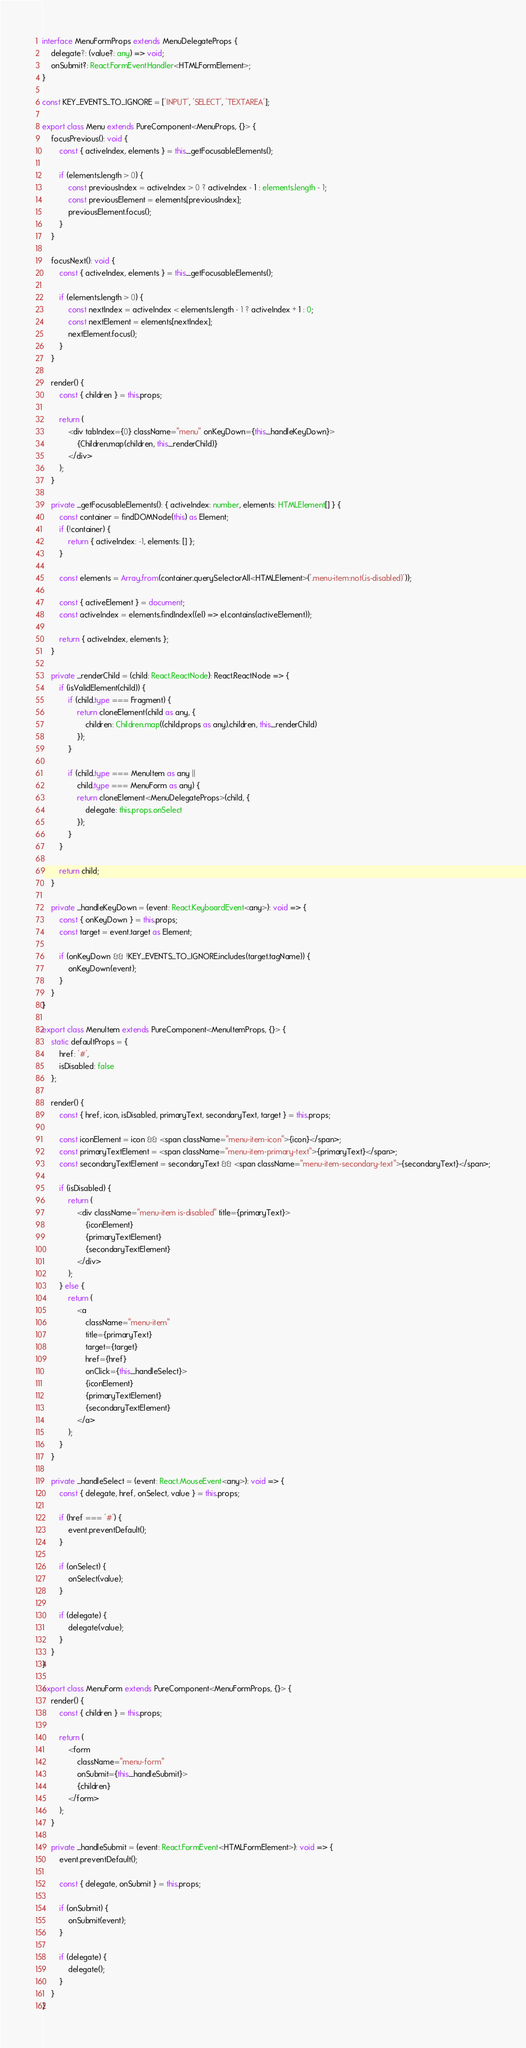<code> <loc_0><loc_0><loc_500><loc_500><_TypeScript_>
interface MenuFormProps extends MenuDelegateProps {
    delegate?: (value?: any) => void;
    onSubmit?: React.FormEventHandler<HTMLFormElement>;
}

const KEY_EVENTS_TO_IGNORE = ['INPUT', 'SELECT', 'TEXTAREA'];

export class Menu extends PureComponent<MenuProps, {}> {
    focusPrevious(): void {
        const { activeIndex, elements } = this._getFocusableElements();

        if (elements.length > 0) {
            const previousIndex = activeIndex > 0 ? activeIndex - 1 : elements.length - 1;
            const previousElement = elements[previousIndex];
            previousElement.focus();
        }
    }

    focusNext(): void {
        const { activeIndex, elements } = this._getFocusableElements();

        if (elements.length > 0) {
            const nextIndex = activeIndex < elements.length - 1 ? activeIndex + 1 : 0;
            const nextElement = elements[nextIndex];
            nextElement.focus();
        }
    }

    render() {
        const { children } = this.props;

        return (
            <div tabIndex={0} className="menu" onKeyDown={this._handleKeyDown}>
                {Children.map(children, this._renderChild)}
            </div>
        );
    }

    private _getFocusableElements(): { activeIndex: number, elements: HTMLElement[] } {
        const container = findDOMNode(this) as Element;
        if (!container) {
            return { activeIndex: -1, elements: [] };
        }

        const elements = Array.from(container.querySelectorAll<HTMLElement>('.menu-item:not(.is-disabled)'));

        const { activeElement } = document;
        const activeIndex = elements.findIndex((el) => el.contains(activeElement));

        return { activeIndex, elements };
    }

    private _renderChild = (child: React.ReactNode): React.ReactNode => {
        if (isValidElement(child)) {
            if (child.type === Fragment) {
                return cloneElement(child as any, {
                    children: Children.map((child.props as any).children, this._renderChild)
                });
            }

            if (child.type === MenuItem as any ||
                child.type === MenuForm as any) {
                return cloneElement<MenuDelegateProps>(child, {
                    delegate: this.props.onSelect
                });
            }
        }

        return child;
    }

    private _handleKeyDown = (event: React.KeyboardEvent<any>): void => {
        const { onKeyDown } = this.props;
        const target = event.target as Element;

        if (onKeyDown && !KEY_EVENTS_TO_IGNORE.includes(target.tagName)) {
            onKeyDown(event);
        }
    }
}

export class MenuItem extends PureComponent<MenuItemProps, {}> {
    static defaultProps = {
        href: '#',
        isDisabled: false
    };

    render() {
        const { href, icon, isDisabled, primaryText, secondaryText, target } = this.props;

        const iconElement = icon && <span className="menu-item-icon">{icon}</span>;
        const primaryTextElement = <span className="menu-item-primary-text">{primaryText}</span>;
        const secondaryTextElement = secondaryText && <span className="menu-item-secondary-text">{secondaryText}</span>;

        if (isDisabled) {
            return (
                <div className="menu-item is-disabled" title={primaryText}>
                    {iconElement}
                    {primaryTextElement}
                    {secondaryTextElement}
                </div>
            );
        } else {
            return (
                <a
                    className="menu-item"
                    title={primaryText}
                    target={target}
                    href={href}
                    onClick={this._handleSelect}>
                    {iconElement}
                    {primaryTextElement}
                    {secondaryTextElement}
                </a>
            );
        }
    }

    private _handleSelect = (event: React.MouseEvent<any>): void => {
        const { delegate, href, onSelect, value } = this.props;

        if (href === '#') {
            event.preventDefault();
        }

        if (onSelect) {
            onSelect(value);
        }

        if (delegate) {
            delegate(value);
        }
    }
}

export class MenuForm extends PureComponent<MenuFormProps, {}> {
    render() {
        const { children } = this.props;

        return (
            <form
                className="menu-form"
                onSubmit={this._handleSubmit}>
                {children}
            </form>
        );
    }

    private _handleSubmit = (event: React.FormEvent<HTMLFormElement>): void => {
        event.preventDefault();

        const { delegate, onSubmit } = this.props;

        if (onSubmit) {
            onSubmit(event);
        }

        if (delegate) {
            delegate();
        }
    }
}
</code> 